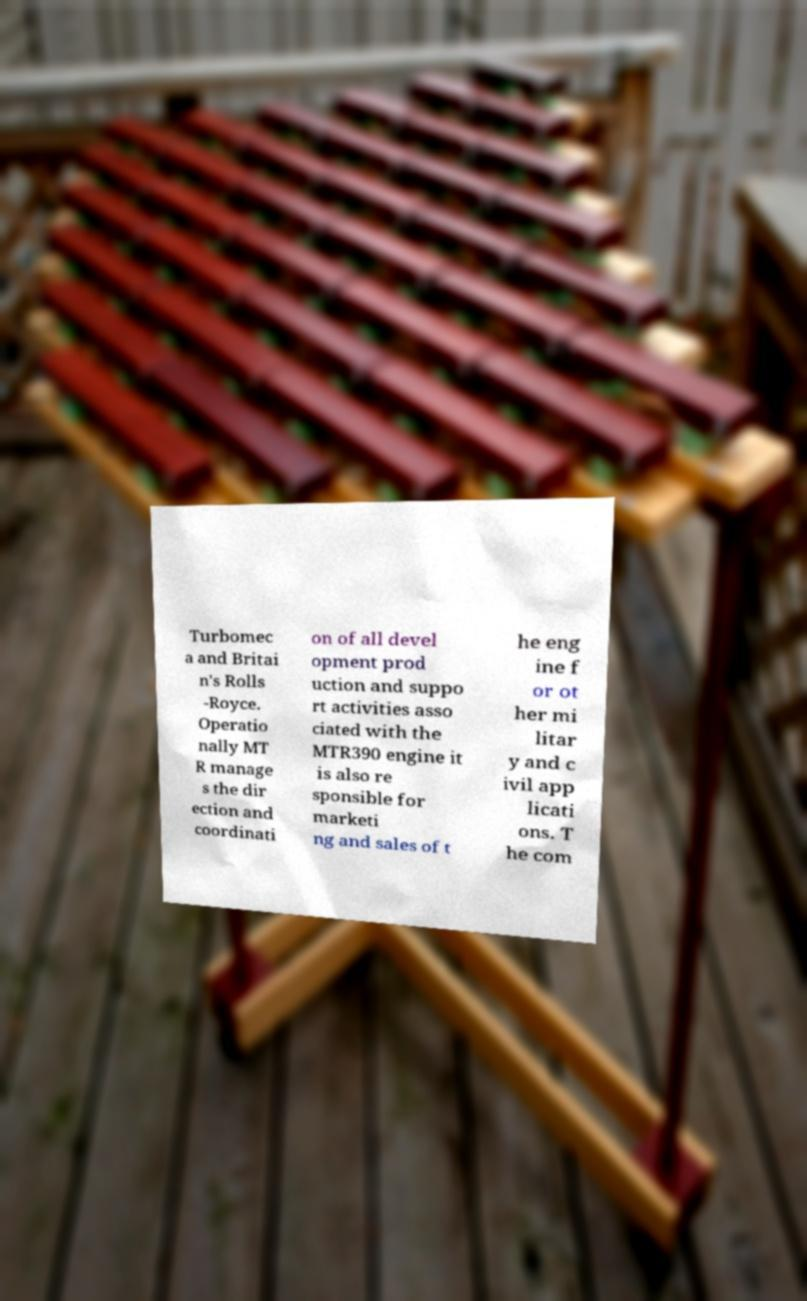Can you read and provide the text displayed in the image?This photo seems to have some interesting text. Can you extract and type it out for me? Turbomec a and Britai n's Rolls -Royce. Operatio nally MT R manage s the dir ection and coordinati on of all devel opment prod uction and suppo rt activities asso ciated with the MTR390 engine it is also re sponsible for marketi ng and sales of t he eng ine f or ot her mi litar y and c ivil app licati ons. T he com 